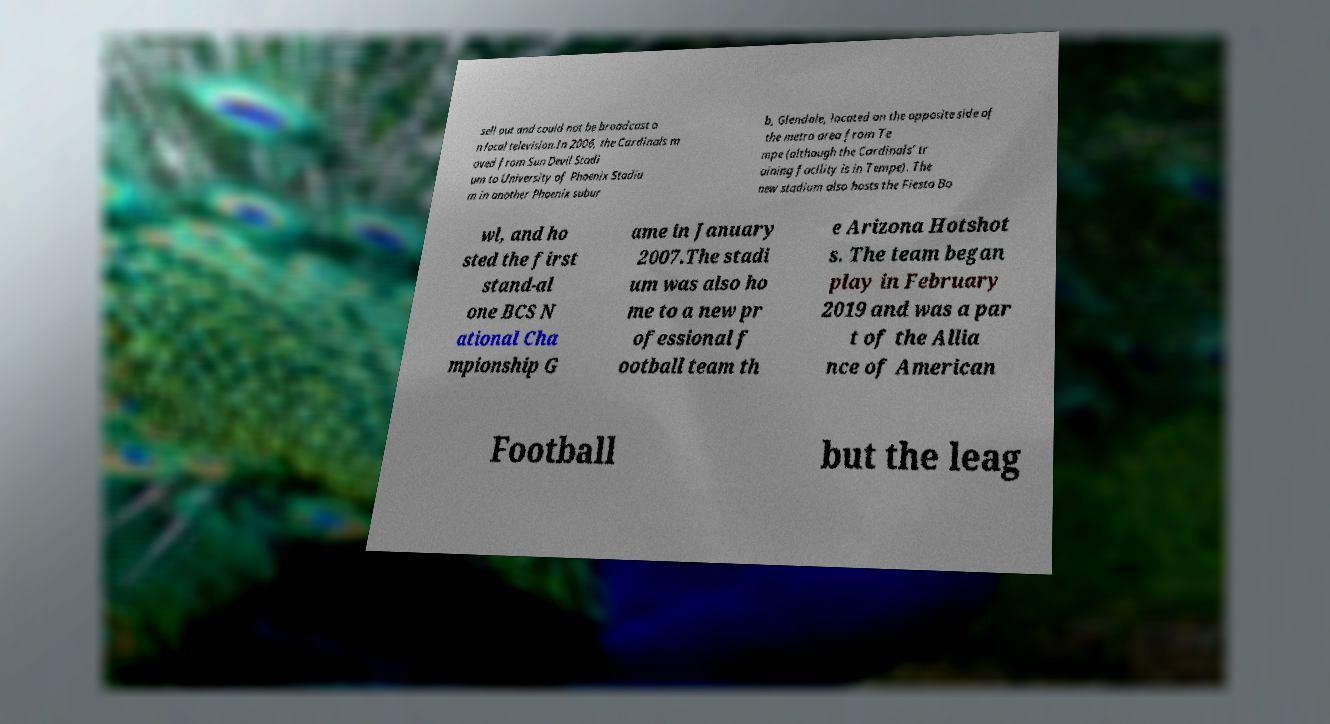Can you read and provide the text displayed in the image?This photo seems to have some interesting text. Can you extract and type it out for me? sell out and could not be broadcast o n local television.In 2006, the Cardinals m oved from Sun Devil Stadi um to University of Phoenix Stadiu m in another Phoenix subur b, Glendale, located on the opposite side of the metro area from Te mpe (although the Cardinals' tr aining facility is in Tempe). The new stadium also hosts the Fiesta Bo wl, and ho sted the first stand-al one BCS N ational Cha mpionship G ame in January 2007.The stadi um was also ho me to a new pr ofessional f ootball team th e Arizona Hotshot s. The team began play in February 2019 and was a par t of the Allia nce of American Football but the leag 